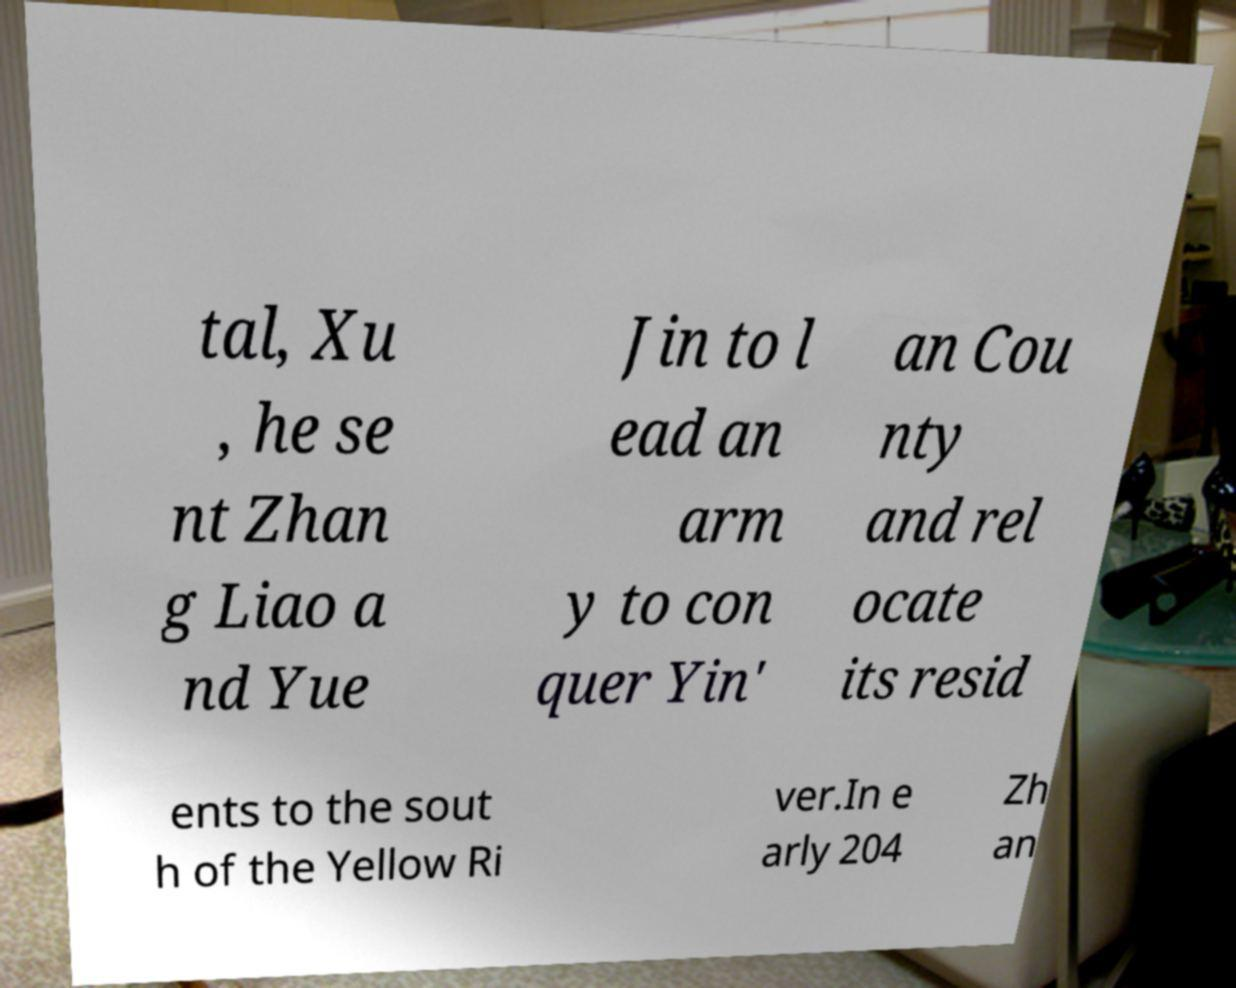Could you extract and type out the text from this image? tal, Xu , he se nt Zhan g Liao a nd Yue Jin to l ead an arm y to con quer Yin' an Cou nty and rel ocate its resid ents to the sout h of the Yellow Ri ver.In e arly 204 Zh an 